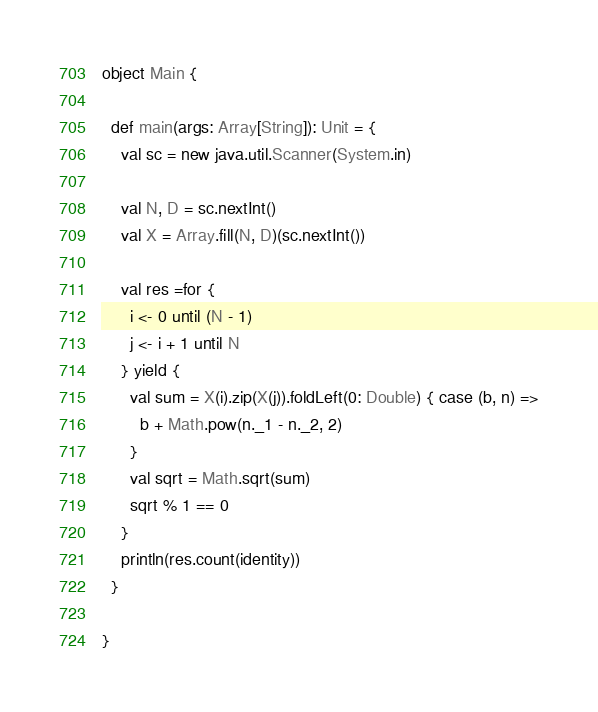<code> <loc_0><loc_0><loc_500><loc_500><_Scala_>object Main {

  def main(args: Array[String]): Unit = {
    val sc = new java.util.Scanner(System.in)

    val N, D = sc.nextInt()
    val X = Array.fill(N, D)(sc.nextInt())

    val res =for {
      i <- 0 until (N - 1)
      j <- i + 1 until N
    } yield {
      val sum = X(i).zip(X(j)).foldLeft(0: Double) { case (b, n) =>
        b + Math.pow(n._1 - n._2, 2)
      }
      val sqrt = Math.sqrt(sum)
      sqrt % 1 == 0
    }
    println(res.count(identity))
  }

}
</code> 